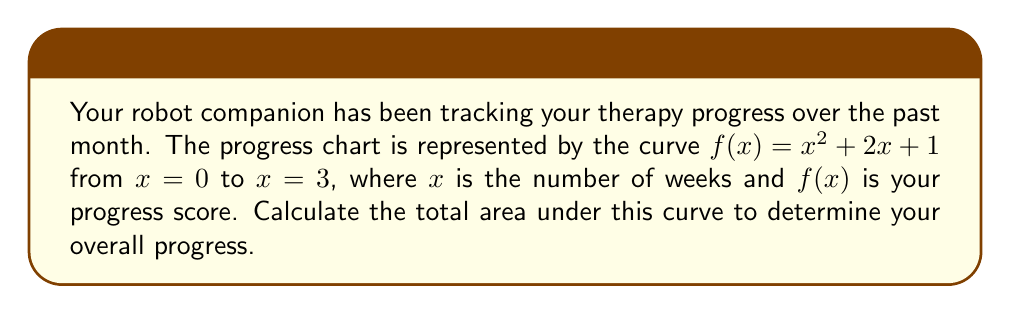Provide a solution to this math problem. To find the area under the curve, we need to integrate the function $f(x) = x^2 + 2x + 1$ from $x = 0$ to $x = 3$. Let's follow these steps:

1) Set up the definite integral:
   $$\int_0^3 (x^2 + 2x + 1) dx$$

2) Integrate each term:
   $$\left[\frac{x^3}{3} + x^2 + x\right]_0^3$$

3) Evaluate the integral at the upper and lower bounds:
   $$\left(\frac{3^3}{3} + 3^2 + 3\right) - \left(\frac{0^3}{3} + 0^2 + 0\right)$$

4) Simplify:
   $$\left(9 + 9 + 3\right) - (0)$$
   $$21 - 0 = 21$$

Therefore, the total area under the curve, representing your overall progress, is 21 units.
Answer: 21 units 